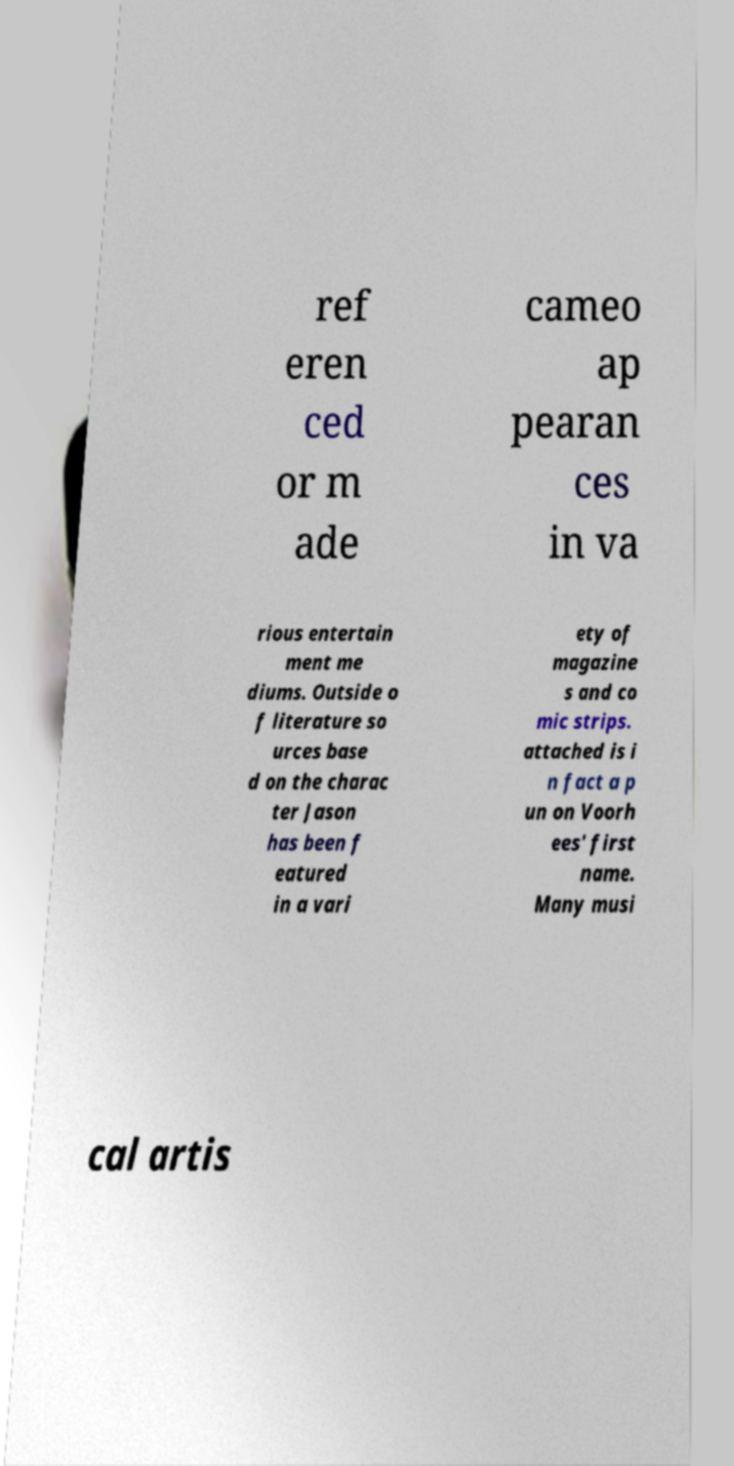There's text embedded in this image that I need extracted. Can you transcribe it verbatim? ref eren ced or m ade cameo ap pearan ces in va rious entertain ment me diums. Outside o f literature so urces base d on the charac ter Jason has been f eatured in a vari ety of magazine s and co mic strips. attached is i n fact a p un on Voorh ees' first name. Many musi cal artis 